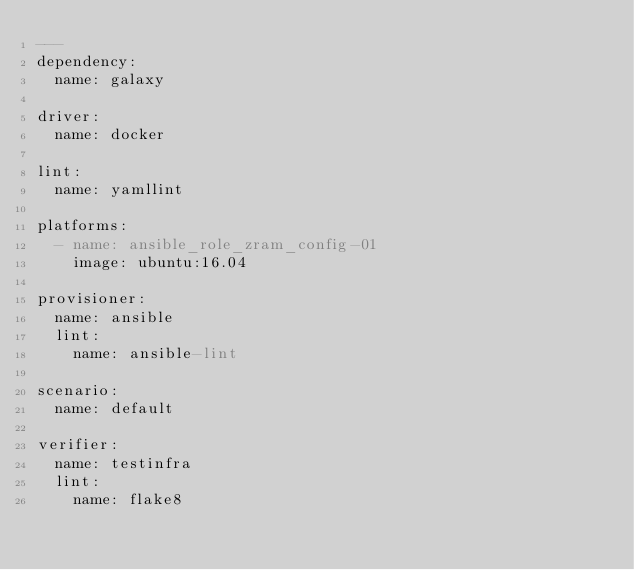Convert code to text. <code><loc_0><loc_0><loc_500><loc_500><_YAML_>---
dependency:
  name: galaxy

driver:
  name: docker

lint:
  name: yamllint

platforms:
  - name: ansible_role_zram_config-01
    image: ubuntu:16.04

provisioner:
  name: ansible
  lint:
    name: ansible-lint

scenario:
  name: default

verifier:
  name: testinfra
  lint:
    name: flake8
</code> 